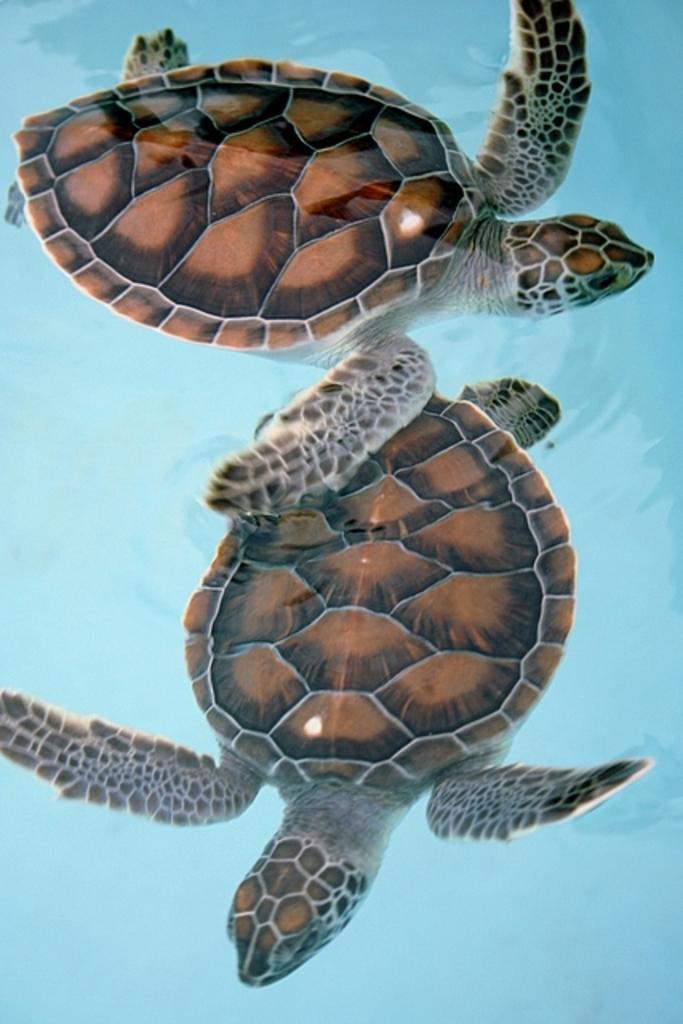In one or two sentences, can you explain what this image depicts? In this image there are two tortoises in the water, the background of the image is blue in color. 